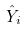Convert formula to latex. <formula><loc_0><loc_0><loc_500><loc_500>\hat { Y } _ { i }</formula> 